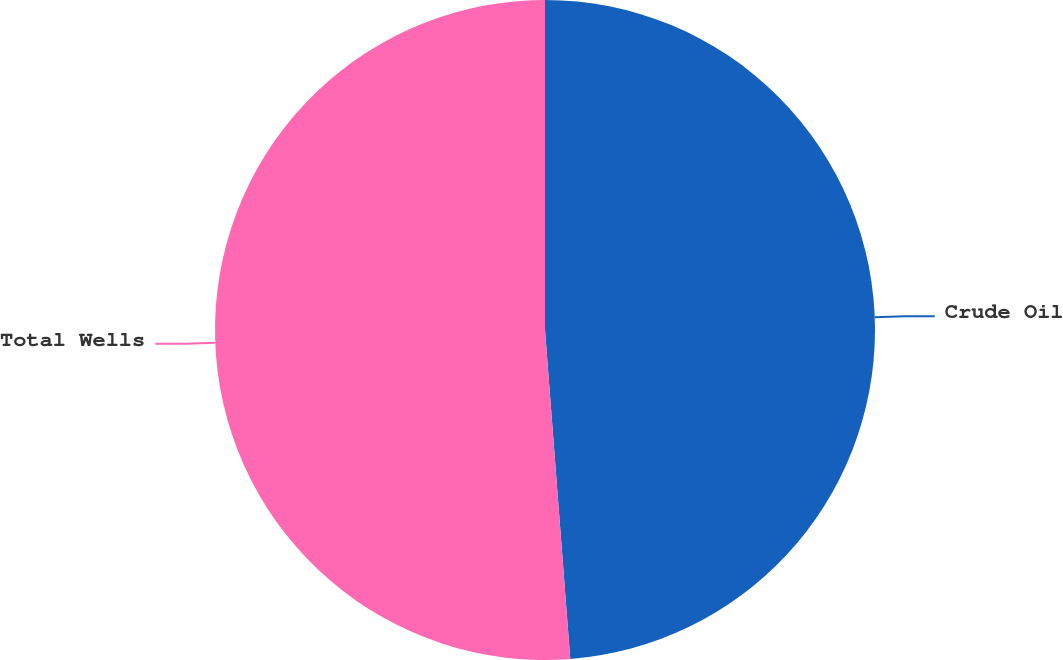<chart> <loc_0><loc_0><loc_500><loc_500><pie_chart><fcel>Crude Oil<fcel>Total Wells<nl><fcel>48.78%<fcel>51.22%<nl></chart> 